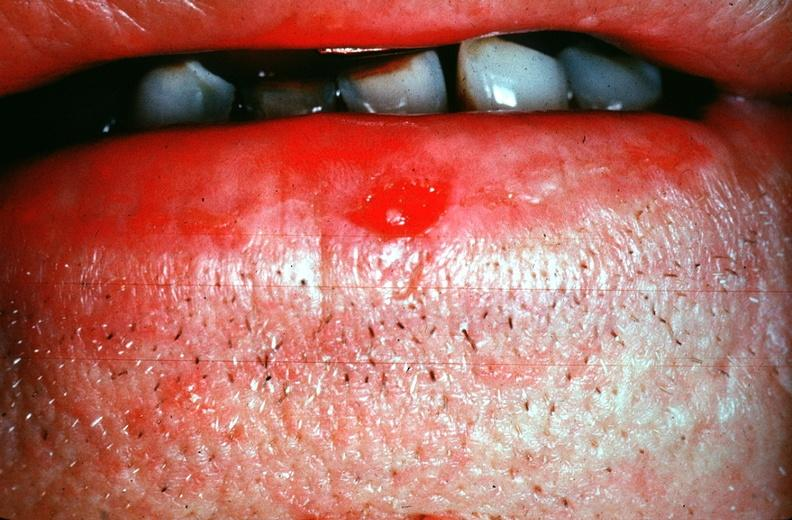what does this image show?
Answer the question using a single word or phrase. Squamous cell carcinoma 